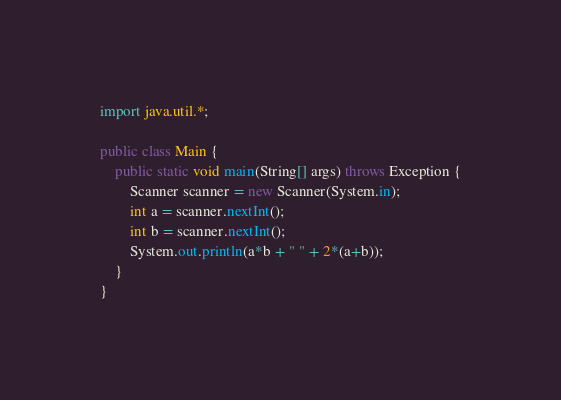<code> <loc_0><loc_0><loc_500><loc_500><_Java_>import java.util.*;

public class Main {
    public static void main(String[] args) throws Exception {
        Scanner scanner = new Scanner(System.in);
        int a = scanner.nextInt();
        int b = scanner.nextInt();
        System.out.println(a*b + " " + 2*(a+b));
    }
}

</code> 